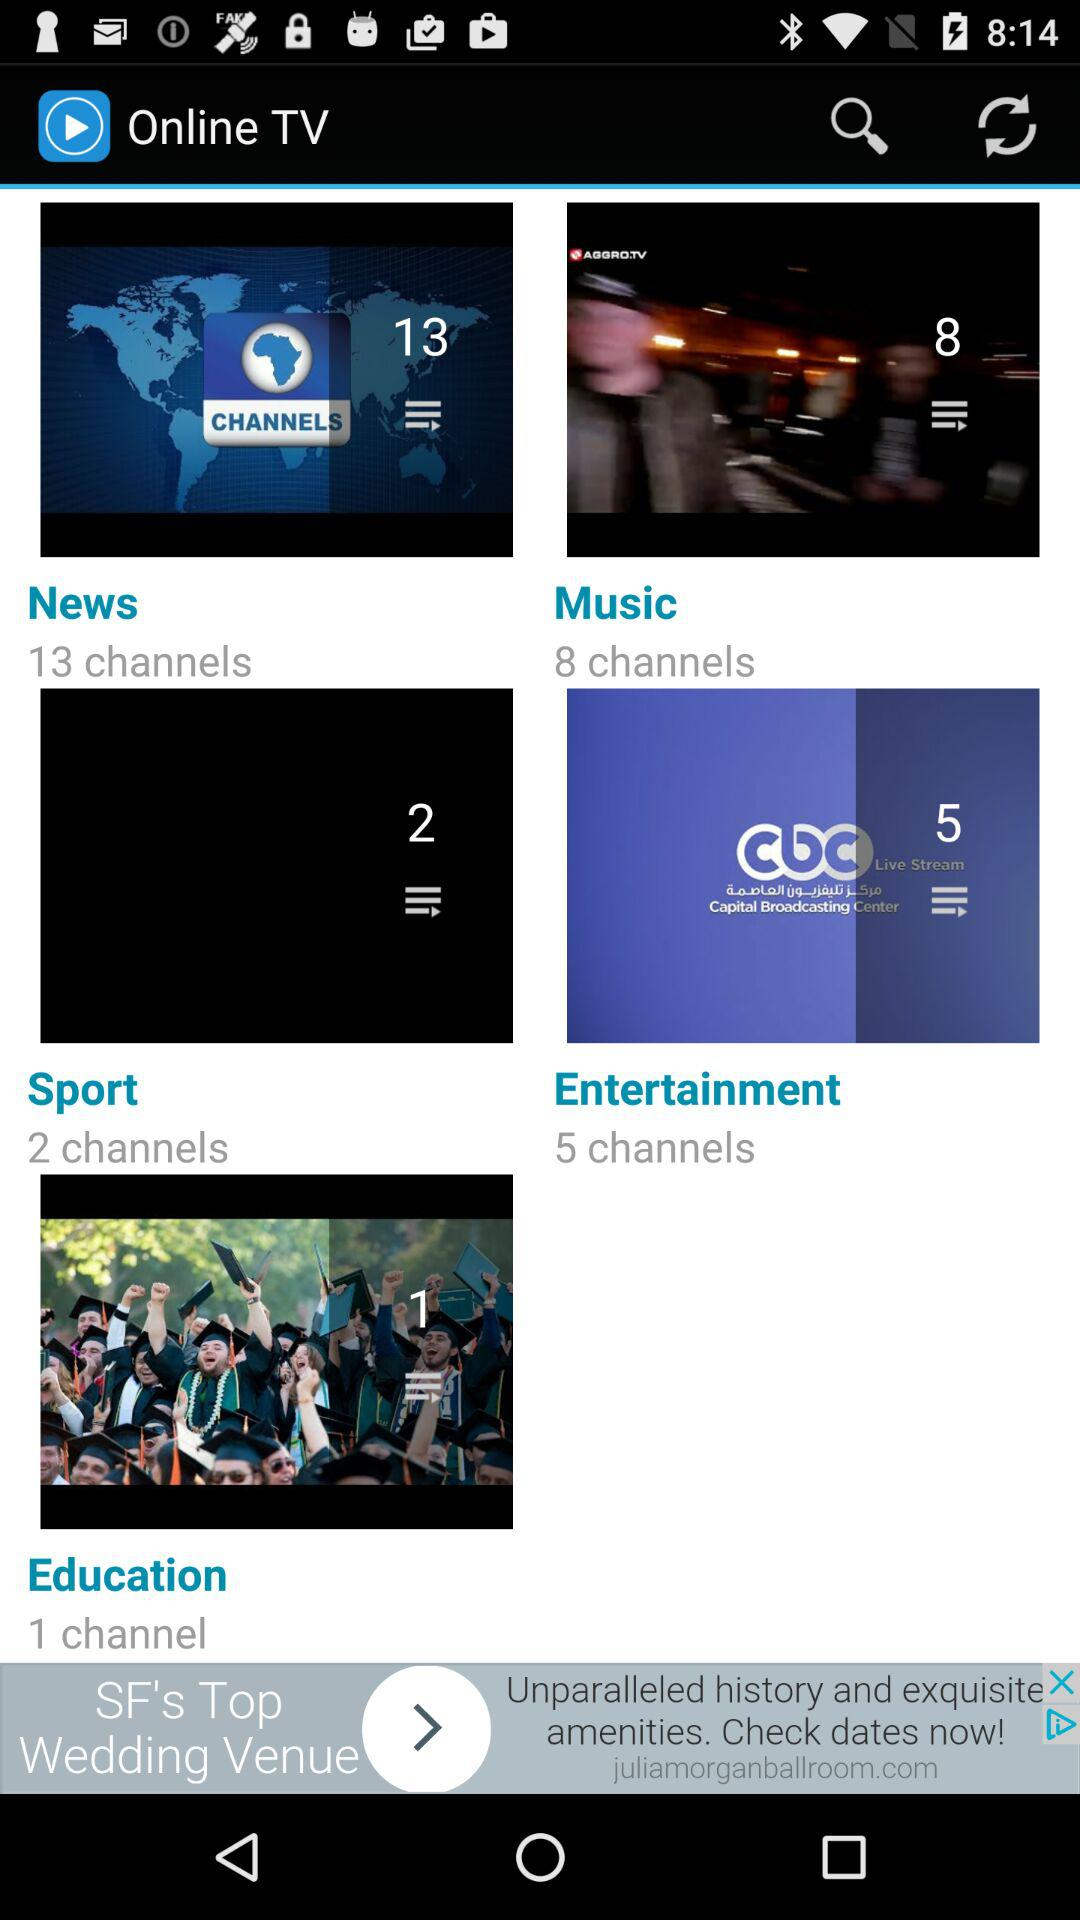How many entertainment channels are there? There are 5 entertainment channels. 